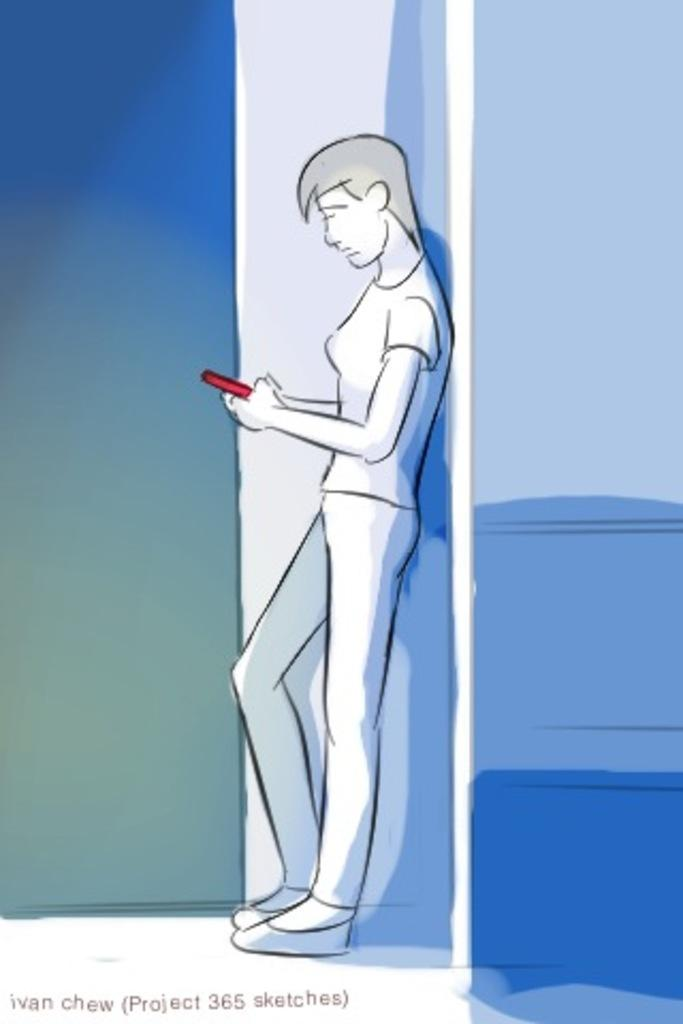Who or what is present in the image? There is a person in the image. What is the person doing in the image? The person is leaning on a wall. What object is the person holding in the image? The person is holding a red mobile phone. What type of cream can be seen on the cat in the image? There is no cat or cream present in the image; it features a person leaning on a wall and holding a red mobile phone. 